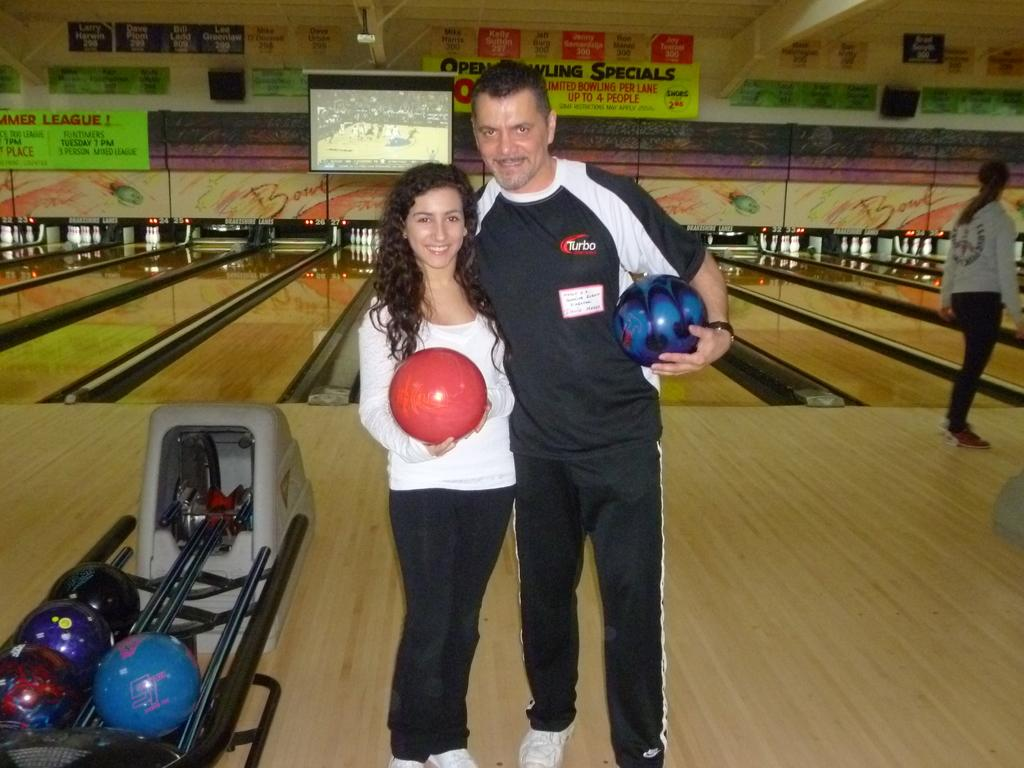<image>
Present a compact description of the photo's key features. To the left upper corner is a lime green sign advertising Summer League. 